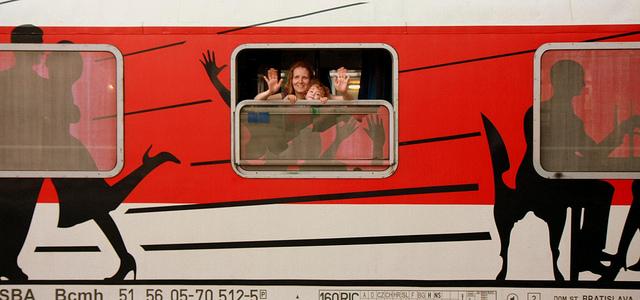What are the people painted on the side of?
Give a very brief answer. Train. Are the people in the window waving?
Quick response, please. Yes. How many people?
Concise answer only. 2. 